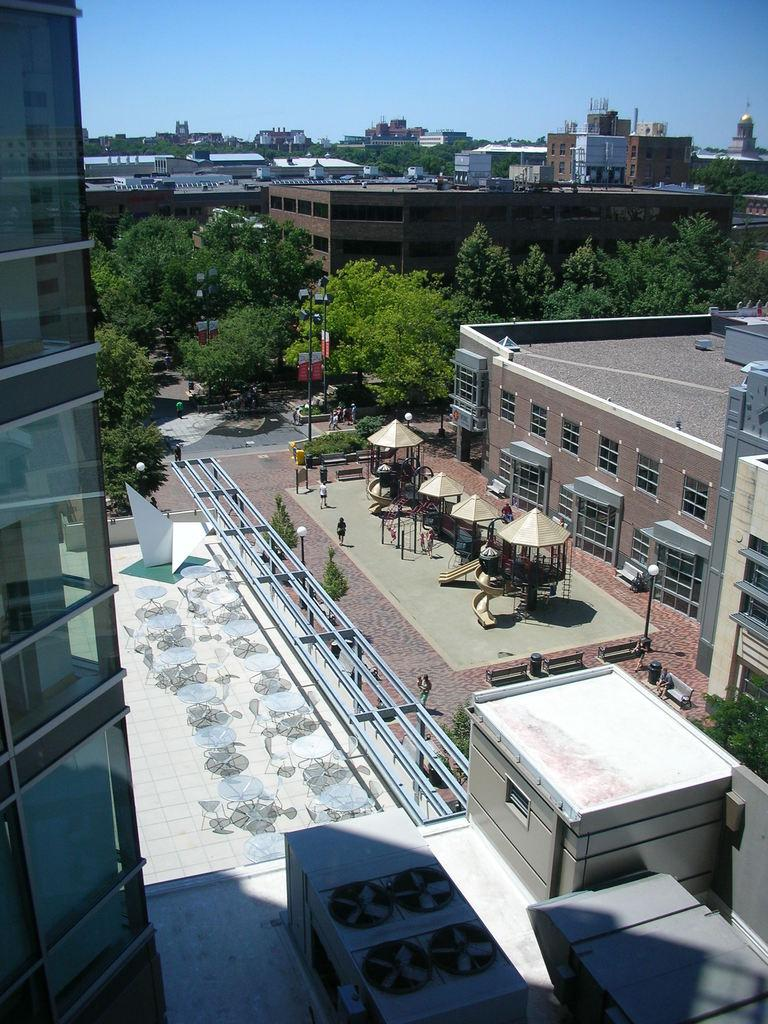What type of location is depicted in the image? The image is of a city. What structures can be seen in the city? There are buildings in the image. Are there any illuminated objects in the image? Yes, there are lights in the image. What type of vertical structures are present in the image? There are poles in the image. What type of signage can be seen in the image? There are boards in the image. What type of natural elements are present in the image? There are trees in the image. What type of transportation infrastructure is present in the image? There is a road in the image. What type of recreational area is present in the image? There is an outdoor playground in the image. Are there any people visible in the image? Yes, there is a group of people standing in the image. What can be seen in the background of the image? The sky is visible in the background of the image. What type of school can be seen in the image? There is no school present in the image. What type of whistle can be heard in the image? There is no whistle present in the image, as it is a still image and cannot produce sound. 